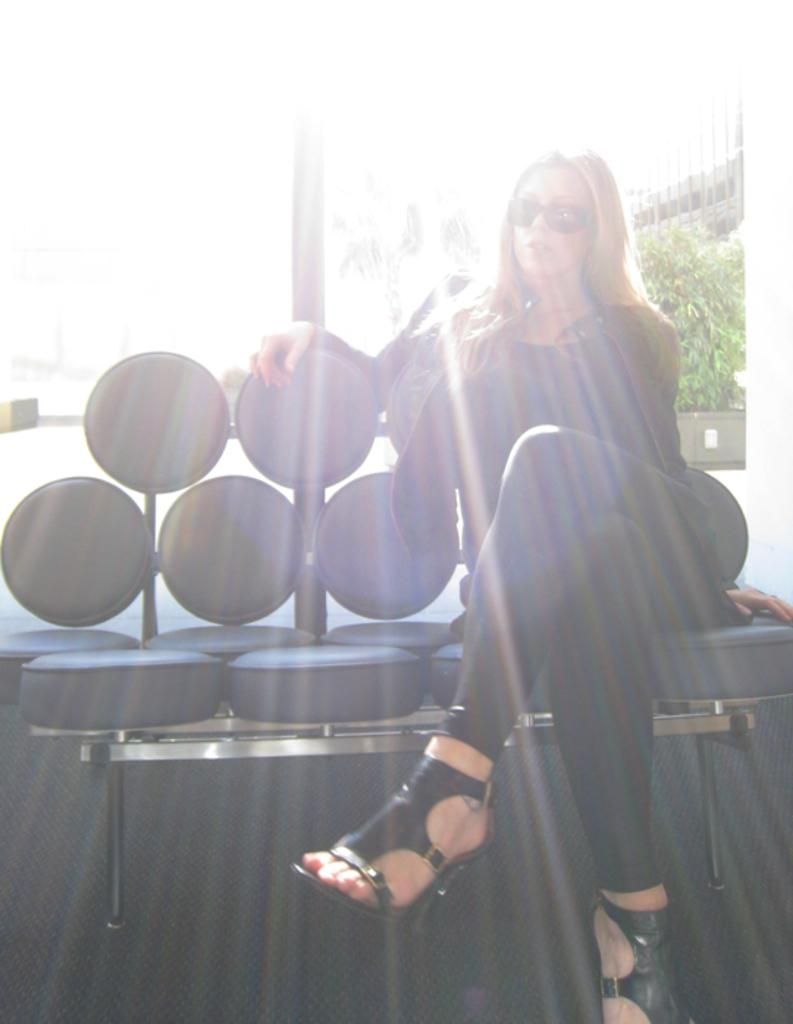What is the woman doing in the image? The woman is sitting on a chair in the image. What can be seen on the right side of the image? There is an object on the right side of the image. What is the purpose of the rod visible in the image? The purpose of the rod is not specified, but it is visible in the image. What type of plant container is present in the image? There is a flower pot in the image. What type of structure can be seen in the background of the image? There is a building in the background of the image. What riddle does the boy ask the woman in the image? There is no boy present in the image, so no riddle can be asked or answered. 